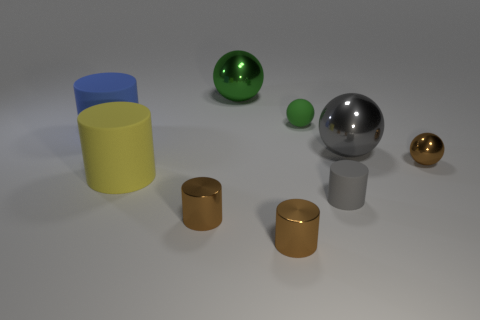Subtract all gray cylinders. How many cylinders are left? 4 Subtract all tiny gray cylinders. How many cylinders are left? 4 Subtract all purple balls. Subtract all green cylinders. How many balls are left? 4 Subtract all cylinders. How many objects are left? 4 Subtract 2 brown cylinders. How many objects are left? 7 Subtract all brown metallic cylinders. Subtract all matte cylinders. How many objects are left? 4 Add 2 blue matte cylinders. How many blue matte cylinders are left? 3 Add 3 large cyan objects. How many large cyan objects exist? 3 